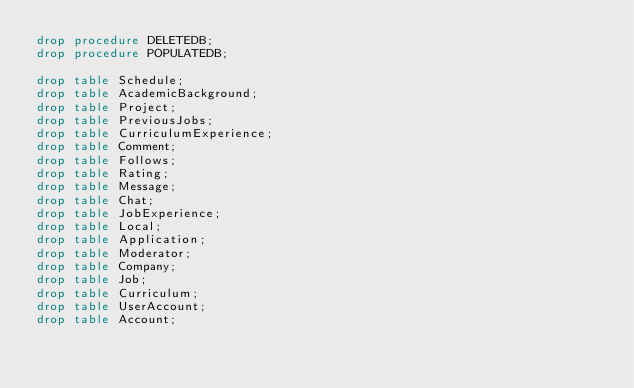Convert code to text. <code><loc_0><loc_0><loc_500><loc_500><_SQL_>drop procedure DELETEDB;
drop procedure POPULATEDB;

drop table Schedule;
drop table AcademicBackground;
drop table Project;
drop table PreviousJobs;
drop table CurriculumExperience;
drop table Comment;
drop table Follows;
drop table Rating;
drop table Message;
drop table Chat;
drop table JobExperience;
drop table Local;
drop table Application;
drop table Moderator;
drop table Company;
drop table Job;
drop table Curriculum;
drop table UserAccount;
drop table Account;</code> 